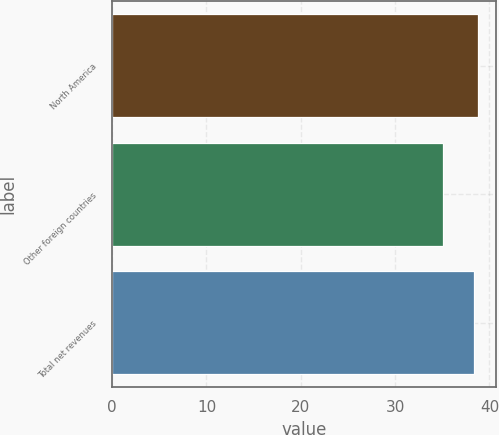<chart> <loc_0><loc_0><loc_500><loc_500><bar_chart><fcel>North America<fcel>Other foreign countries<fcel>Total net revenues<nl><fcel>38.75<fcel>35.1<fcel>38.4<nl></chart> 